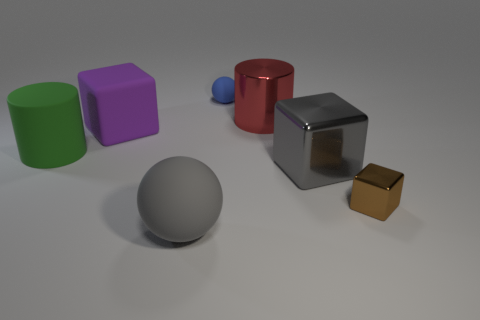Subtract all big rubber blocks. How many blocks are left? 2 Subtract all red cylinders. How many cylinders are left? 1 Subtract 1 cylinders. How many cylinders are left? 1 Add 2 blue rubber balls. How many objects exist? 9 Subtract all large matte things. Subtract all cubes. How many objects are left? 1 Add 7 small things. How many small things are left? 9 Add 1 gray balls. How many gray balls exist? 2 Subtract 1 gray spheres. How many objects are left? 6 Subtract all cubes. How many objects are left? 4 Subtract all purple cubes. Subtract all gray spheres. How many cubes are left? 2 